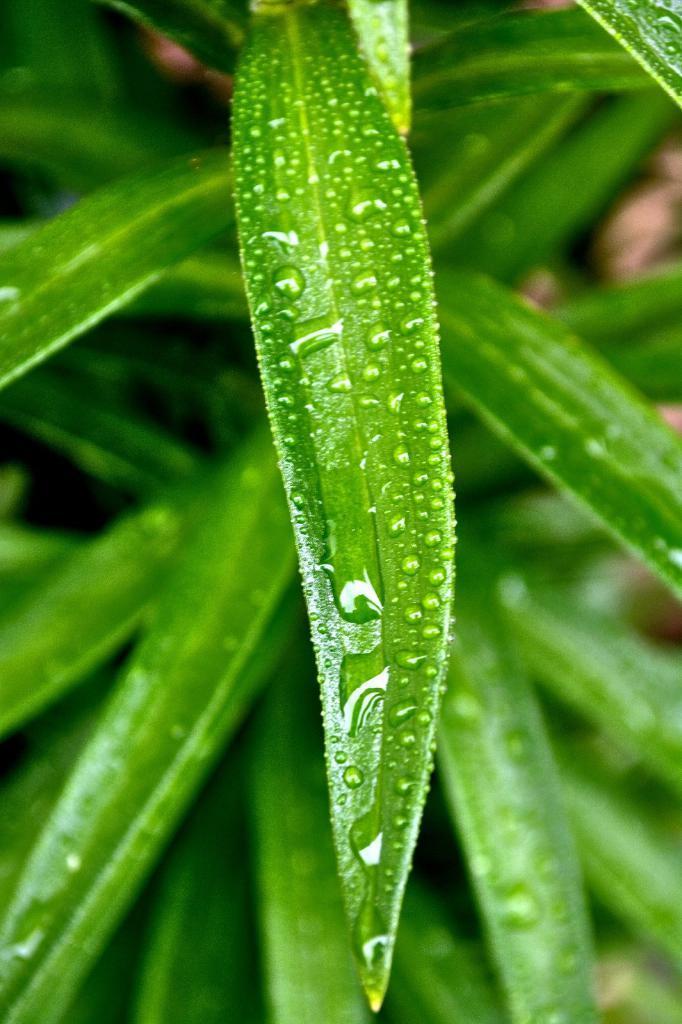In one or two sentences, can you explain what this image depicts? In this picture we can see plant. On the leaf we can see water drops. At the bottom we can see many leaves. 